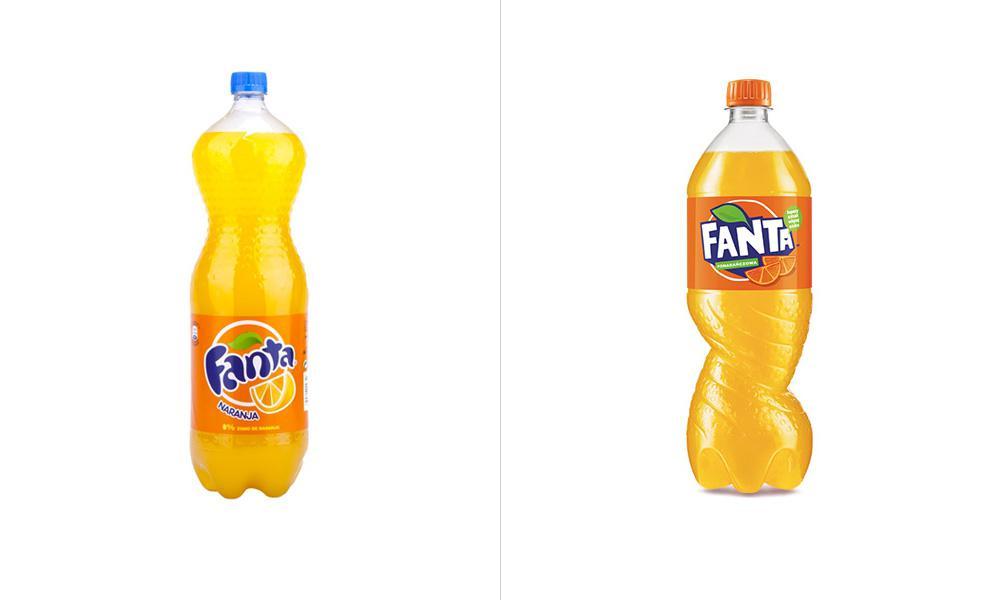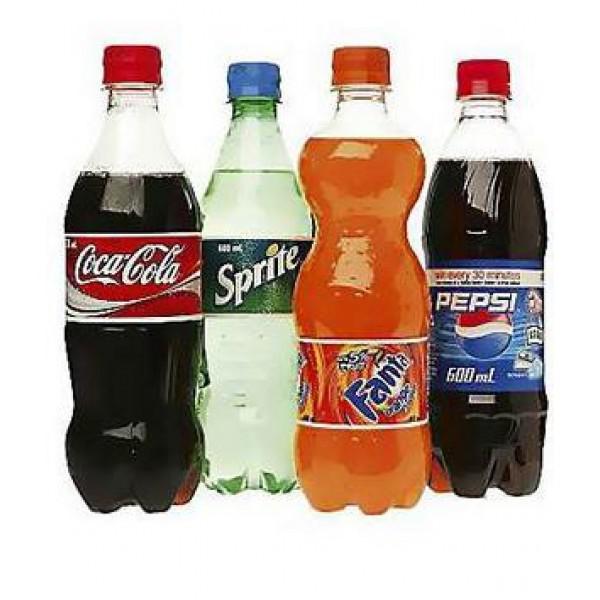The first image is the image on the left, the second image is the image on the right. Considering the images on both sides, is "All the containers are plastic." valid? Answer yes or no. Yes. The first image is the image on the left, the second image is the image on the right. Given the left and right images, does the statement "One of the images includes fewer than three drink containers." hold true? Answer yes or no. Yes. 